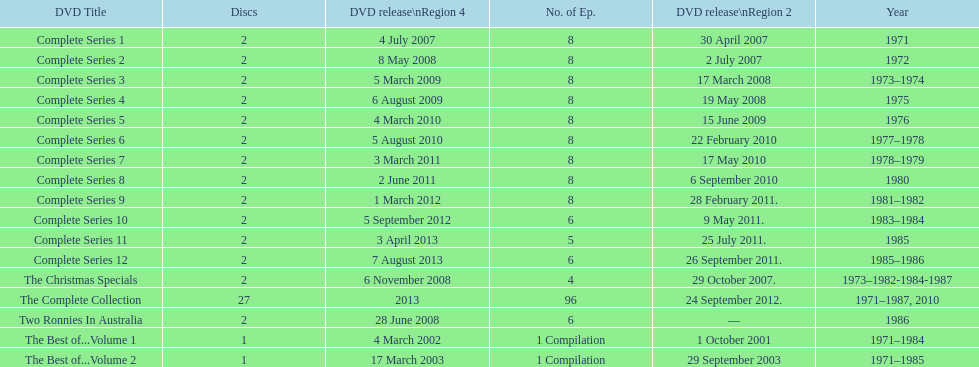The complete collection has 96 episodes, but the christmas specials only has how many episodes? 4. 